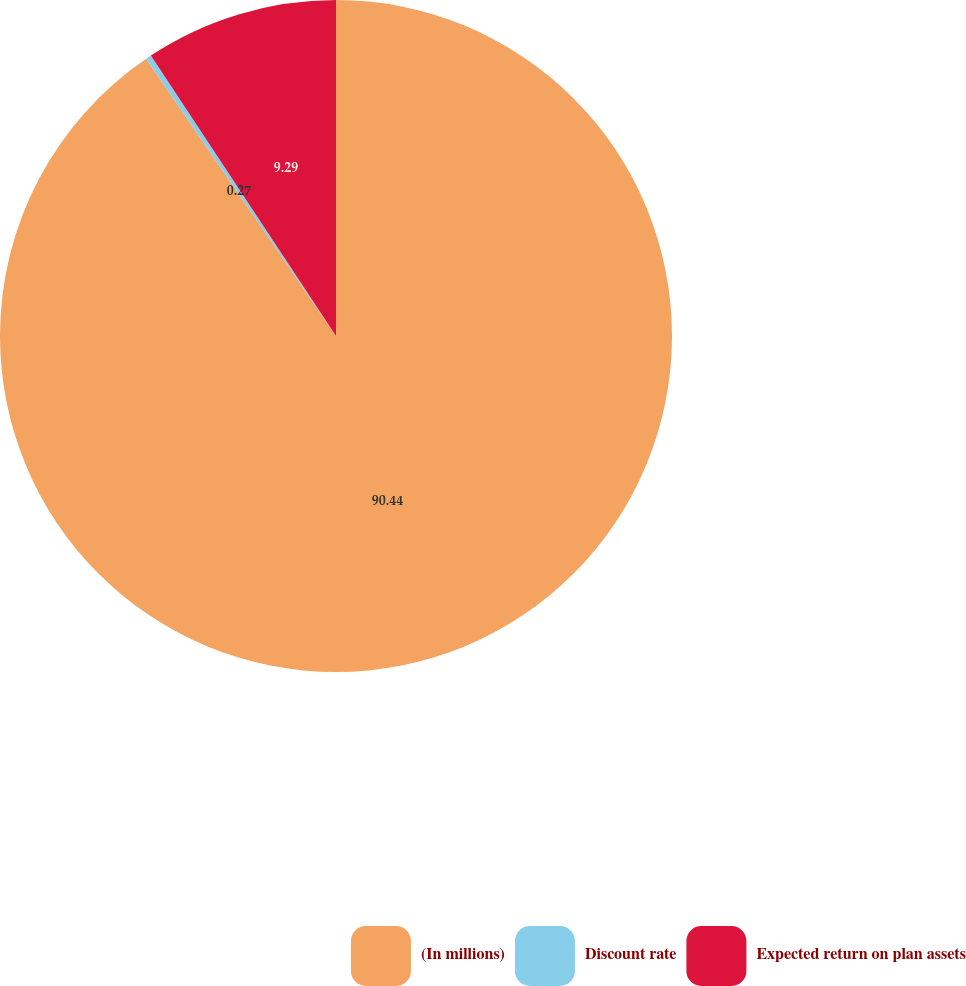Convert chart. <chart><loc_0><loc_0><loc_500><loc_500><pie_chart><fcel>(In millions)<fcel>Discount rate<fcel>Expected return on plan assets<nl><fcel>90.45%<fcel>0.27%<fcel>9.29%<nl></chart> 